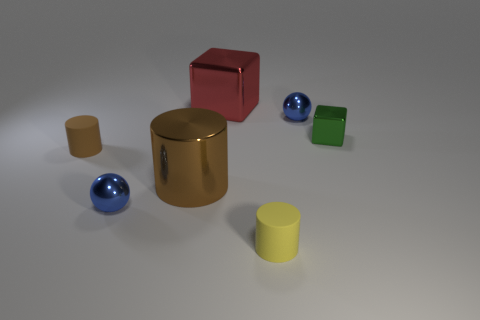How many other things are there of the same size as the brown rubber object?
Offer a very short reply. 4. There is a yellow cylinder in front of the small blue shiny thing that is to the left of the cube to the left of the tiny yellow matte cylinder; what is its material?
Offer a very short reply. Rubber. What number of balls are either red metallic objects or small green shiny objects?
Provide a succinct answer. 0. Are there any other things that are the same shape as the yellow thing?
Provide a succinct answer. Yes. Are there more tiny yellow matte things that are behind the brown metal cylinder than brown matte cylinders to the right of the tiny brown matte object?
Offer a very short reply. No. There is a big metal thing to the left of the big red metal block; how many green metallic blocks are on the right side of it?
Offer a terse response. 1. What number of objects are either tiny green metallic cubes or large cyan shiny objects?
Ensure brevity in your answer.  1. Does the green thing have the same shape as the yellow thing?
Ensure brevity in your answer.  No. What material is the large red cube?
Your answer should be very brief. Metal. How many metal things are both on the left side of the green metallic object and in front of the large metallic cube?
Your answer should be very brief. 3. 